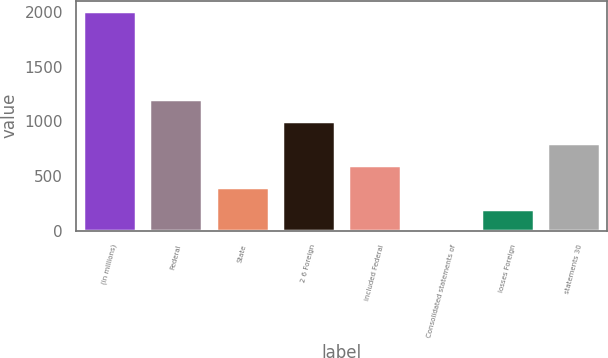Convert chart. <chart><loc_0><loc_0><loc_500><loc_500><bar_chart><fcel>(in millions)<fcel>Federal<fcel>State<fcel>2 6 Foreign<fcel>included Federal<fcel>Consolidated statements of<fcel>losses Foreign<fcel>statements 30<nl><fcel>2003<fcel>1202.2<fcel>401.4<fcel>1002<fcel>601.6<fcel>1<fcel>201.2<fcel>801.8<nl></chart> 